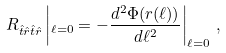Convert formula to latex. <formula><loc_0><loc_0><loc_500><loc_500>R _ { \hat { t } \hat { r } \hat { t } \hat { r } } \left | _ { \ell = 0 } = - \frac { d ^ { 2 } \Phi ( r ( \ell ) ) } { d \ell ^ { 2 } } \right | _ { \ell = 0 } \, ,</formula> 